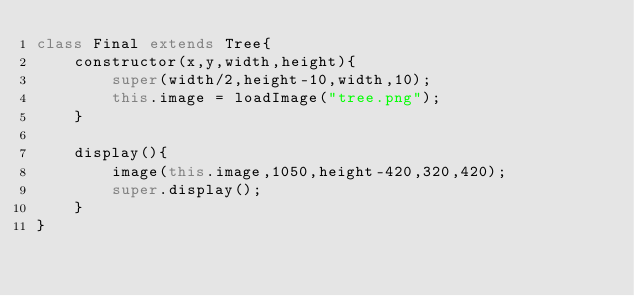<code> <loc_0><loc_0><loc_500><loc_500><_JavaScript_>class Final extends Tree{
    constructor(x,y,width,height){
        super(width/2,height-10,width,10);
        this.image = loadImage("tree.png");
    }

    display(){
        image(this.image,1050,height-420,320,420);
        super.display();
    }
}</code> 